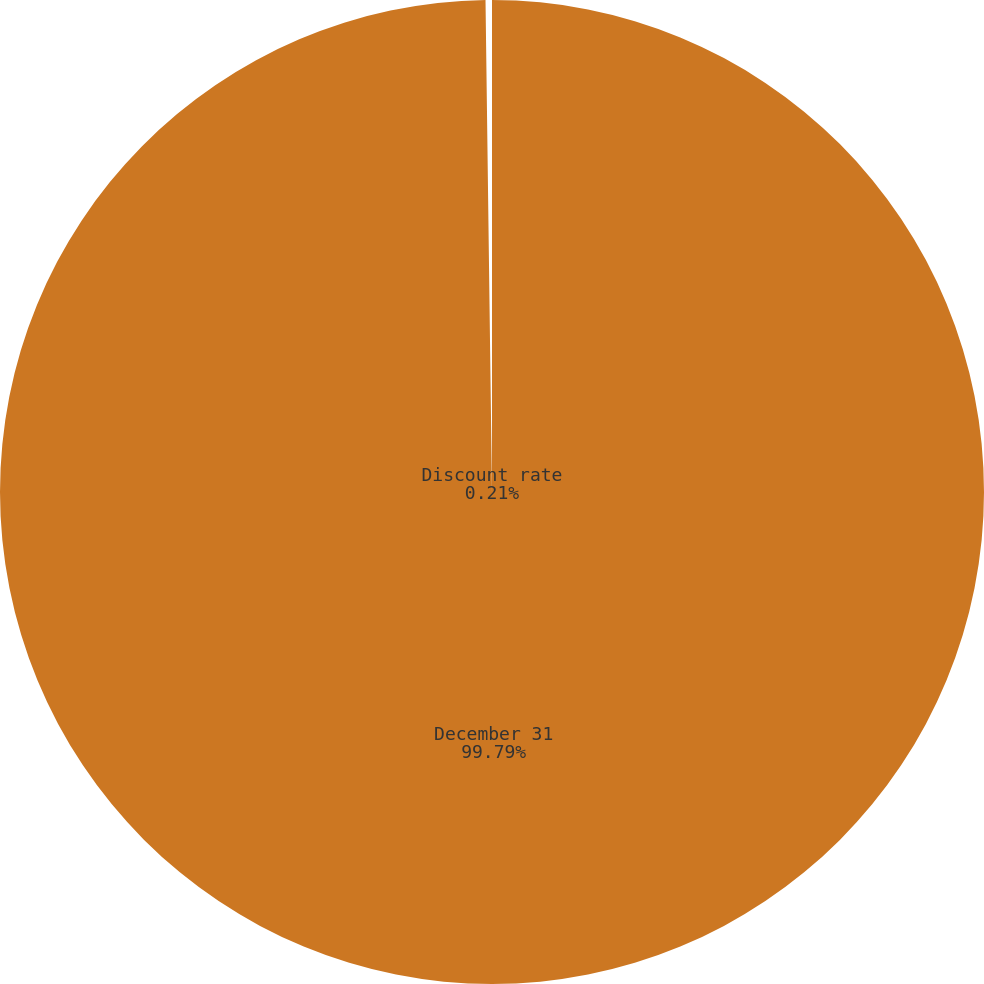<chart> <loc_0><loc_0><loc_500><loc_500><pie_chart><fcel>December 31<fcel>Discount rate<nl><fcel>99.79%<fcel>0.21%<nl></chart> 